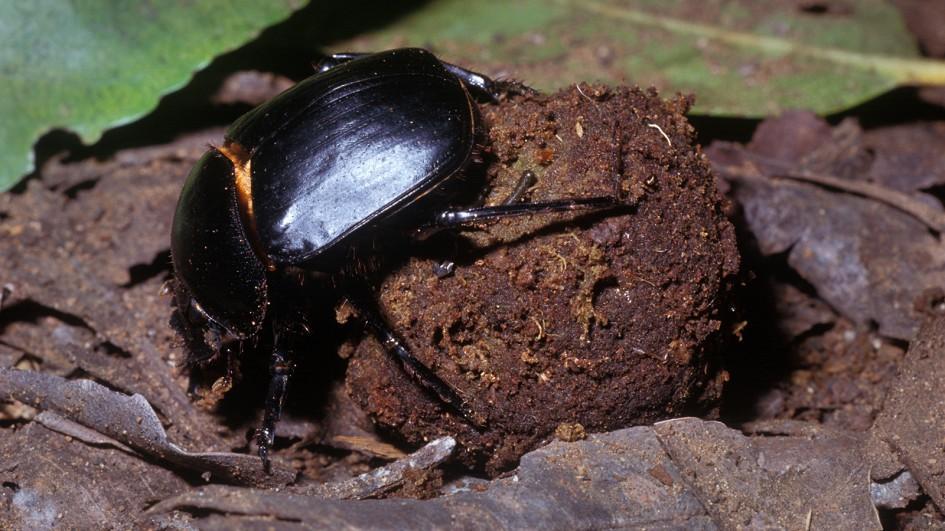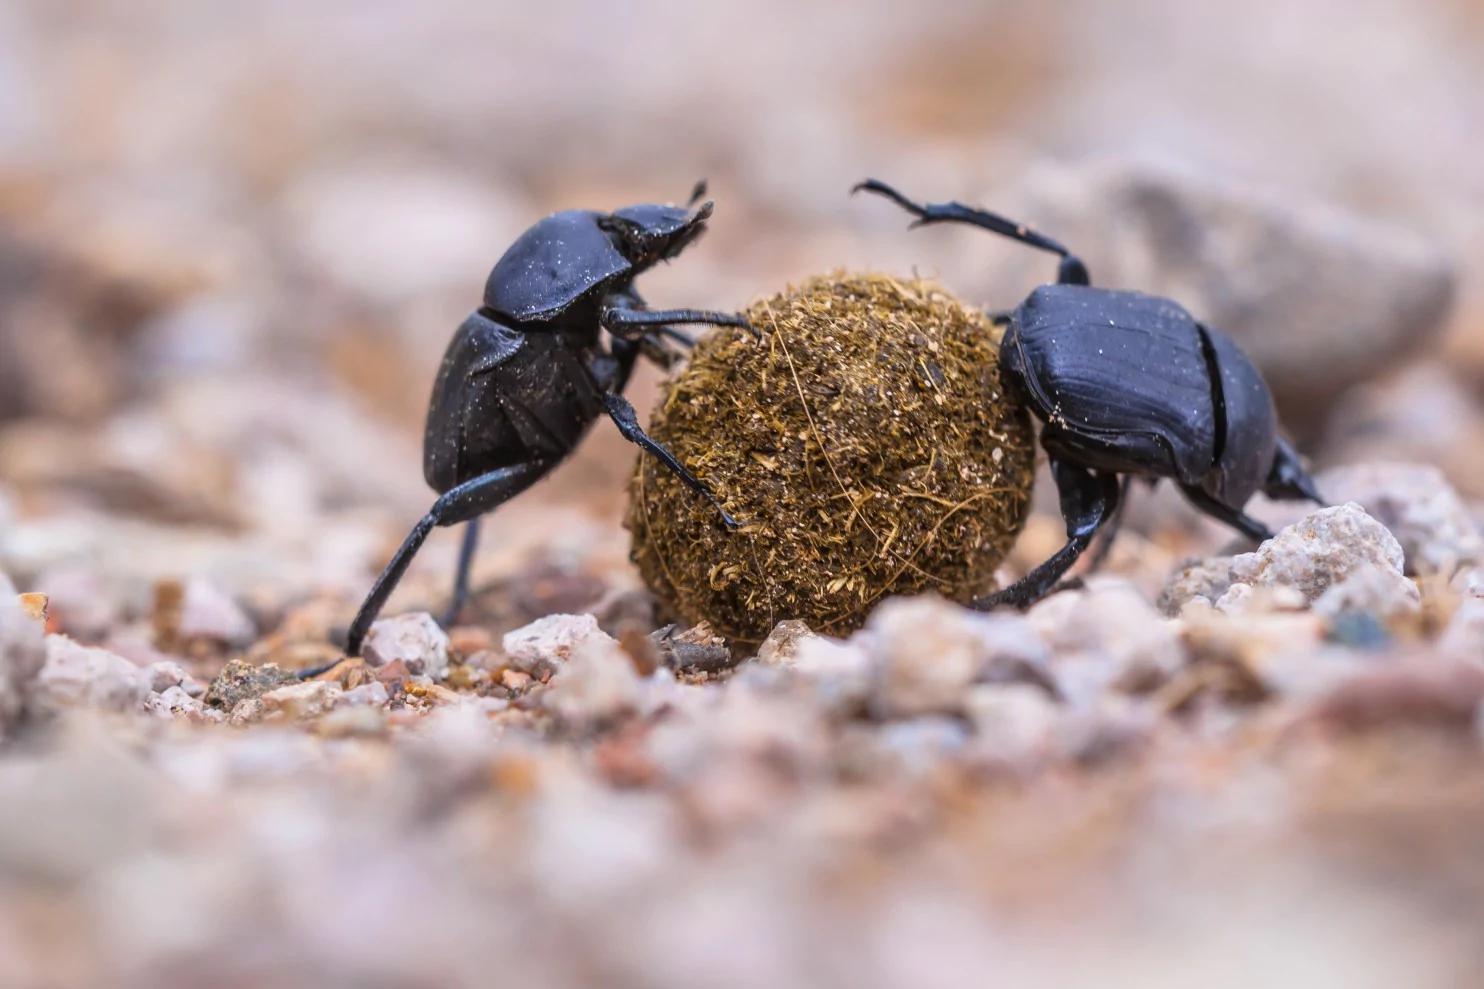The first image is the image on the left, the second image is the image on the right. Examine the images to the left and right. Is the description "One image features two beetles on opposite sides of a dung ball." accurate? Answer yes or no. Yes. 